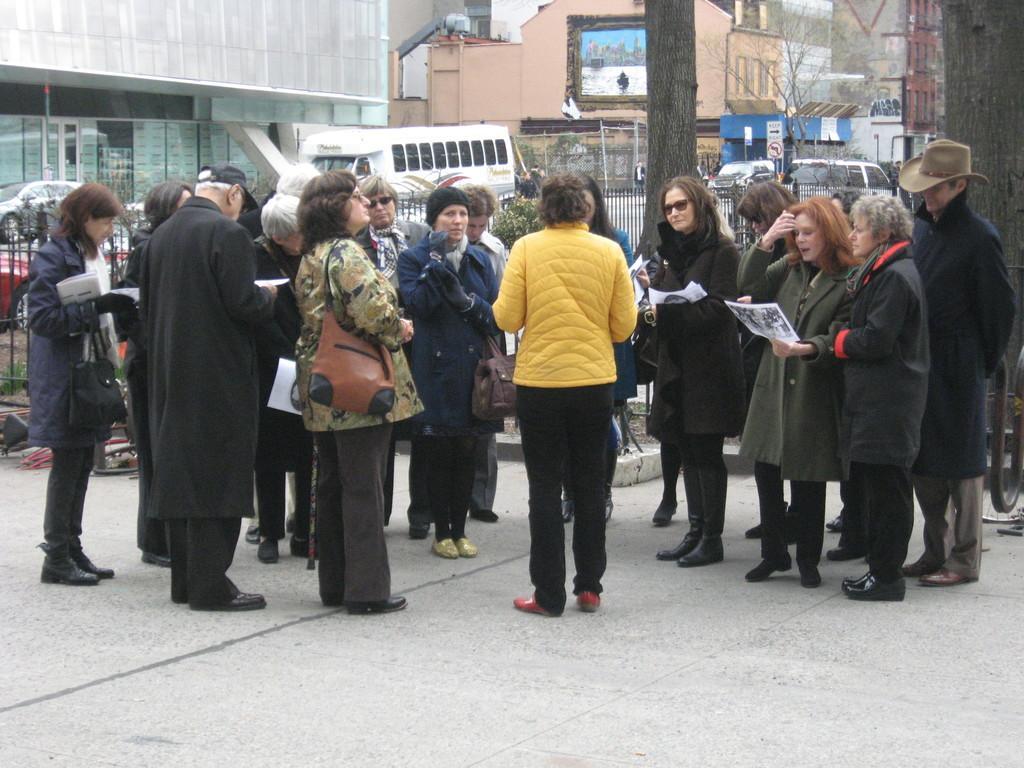Could you give a brief overview of what you see in this image? In this image we can see a group of people standing on the ground. In that some people are holding the papers. On the backside we can see a group of buildings, some vehicles, a fence and the bark of the trees. 